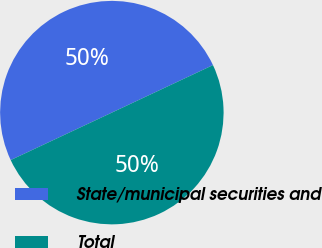Convert chart to OTSL. <chart><loc_0><loc_0><loc_500><loc_500><pie_chart><fcel>State/municipal securities and<fcel>Total<nl><fcel>49.99%<fcel>50.01%<nl></chart> 